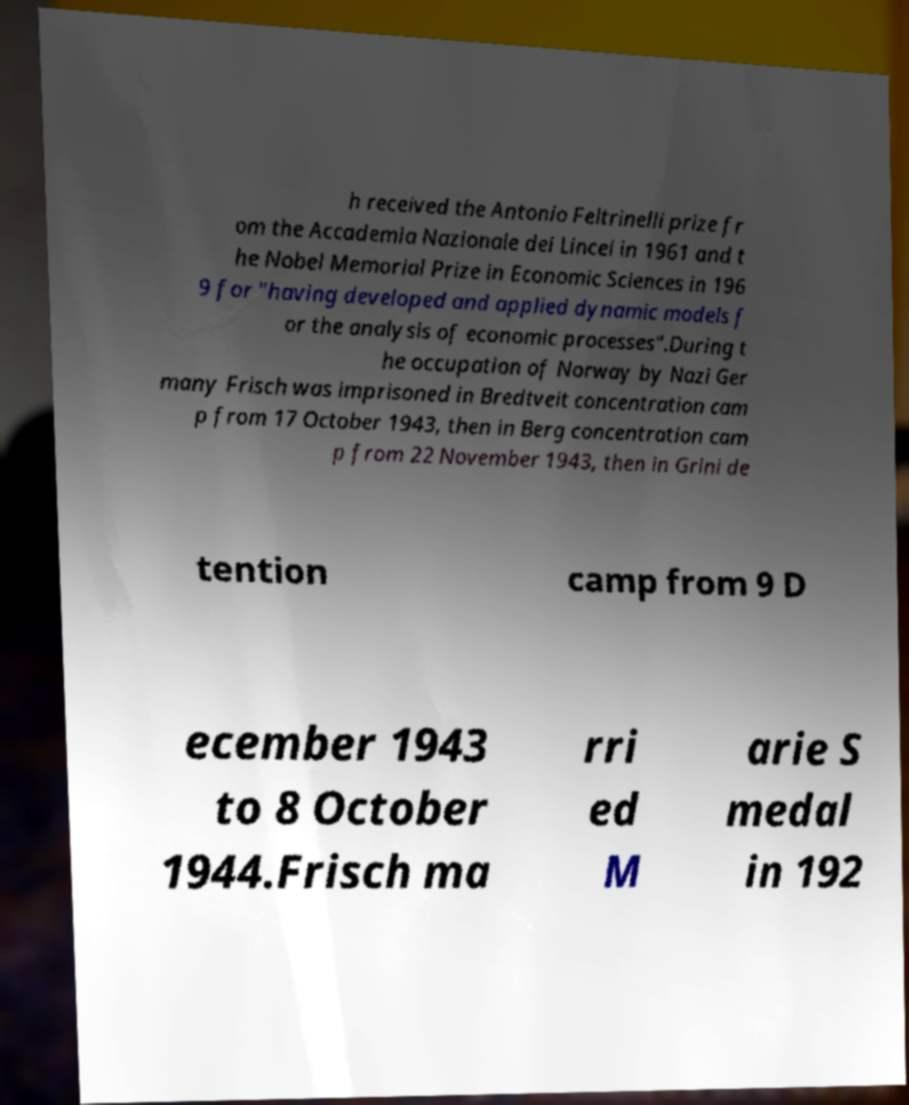Could you extract and type out the text from this image? h received the Antonio Feltrinelli prize fr om the Accademia Nazionale dei Lincei in 1961 and t he Nobel Memorial Prize in Economic Sciences in 196 9 for "having developed and applied dynamic models f or the analysis of economic processes".During t he occupation of Norway by Nazi Ger many Frisch was imprisoned in Bredtveit concentration cam p from 17 October 1943, then in Berg concentration cam p from 22 November 1943, then in Grini de tention camp from 9 D ecember 1943 to 8 October 1944.Frisch ma rri ed M arie S medal in 192 